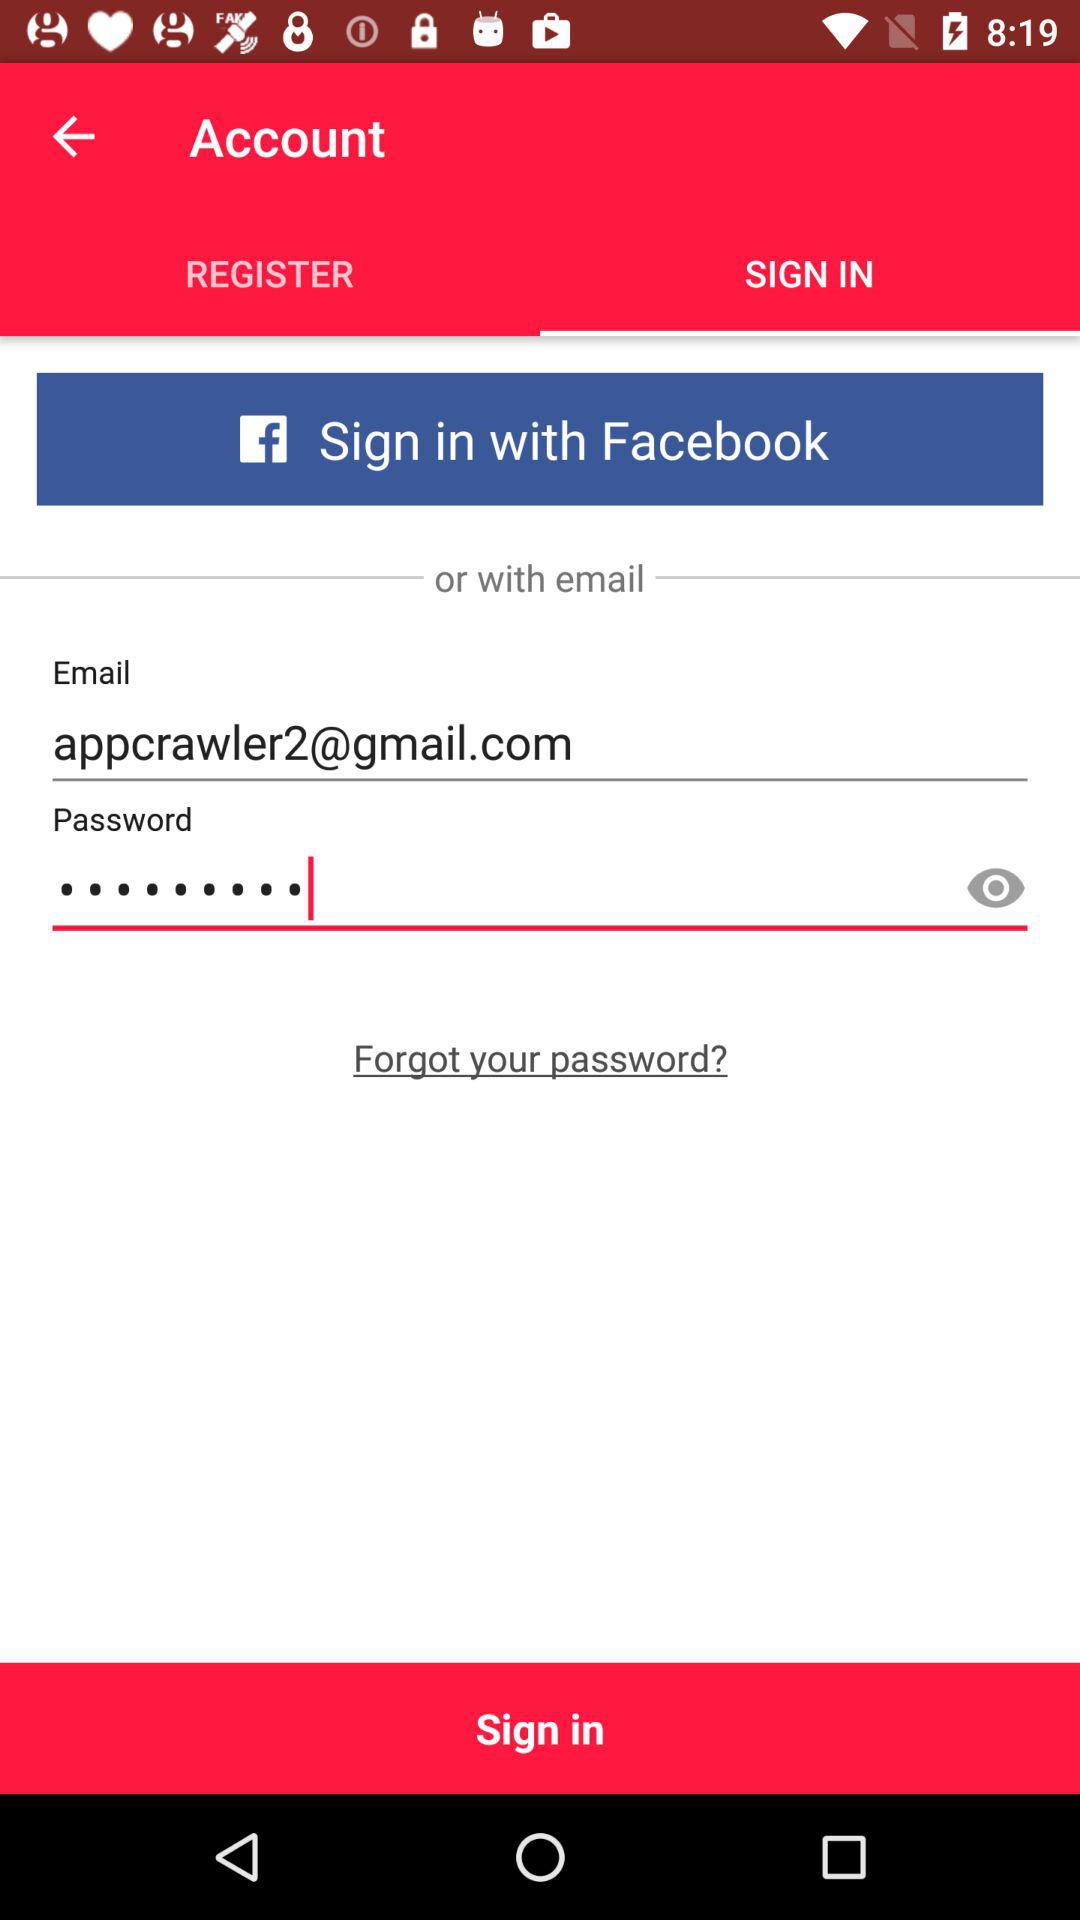How many characters are required to create a password?
When the provided information is insufficient, respond with <no answer>. <no answer> 